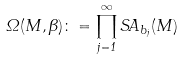Convert formula to latex. <formula><loc_0><loc_0><loc_500><loc_500>\Omega ( M , \beta ) \colon = \prod ^ { \infty } _ { j = 1 } S A _ { b _ { j } } ( M )</formula> 